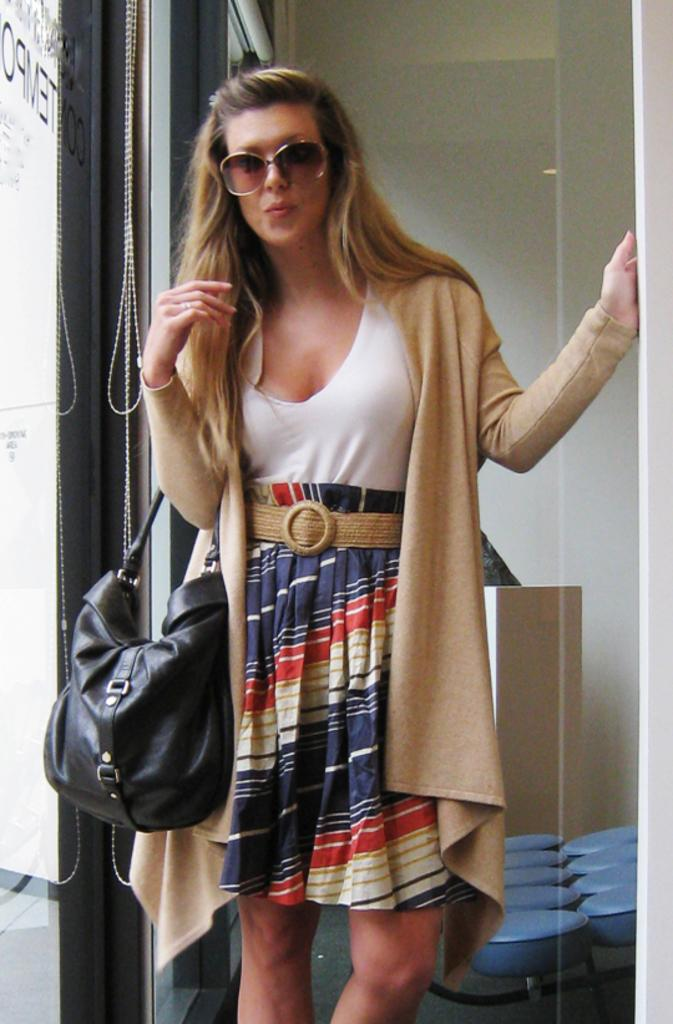Who is the main subject in the image? There is a woman in the image. What is the woman holding in her right hand? The woman is holding a black handbag in her right hand. What is the woman's posture in the image? The woman is standing. What type of ear is visible on the woman's chicken in the image? There is no chicken or ear present in the image; it features a woman holding a black handbag. 